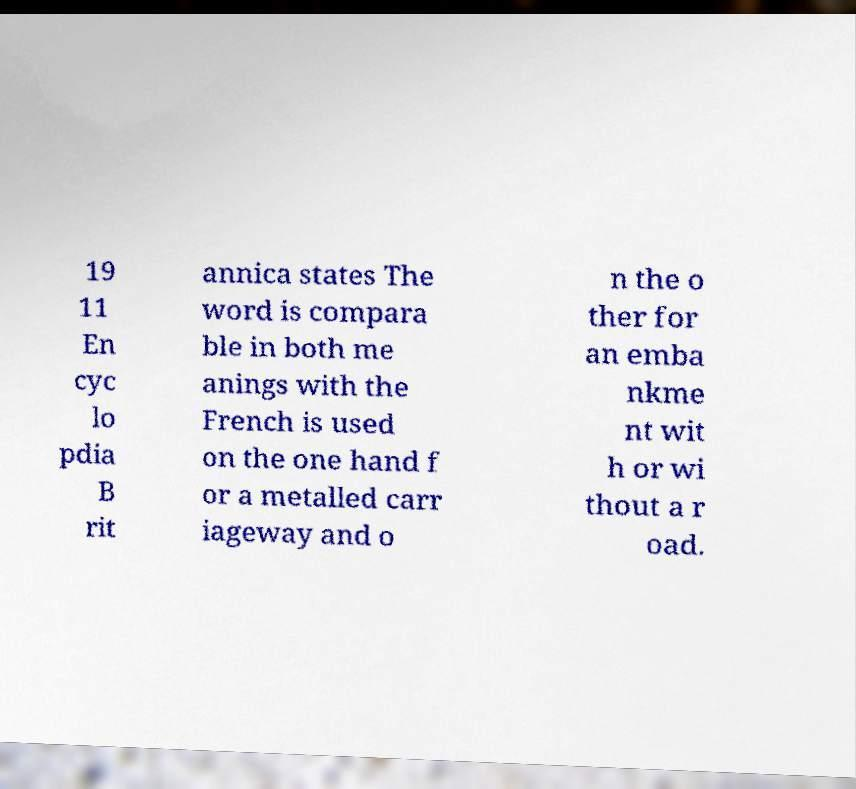What messages or text are displayed in this image? I need them in a readable, typed format. 19 11 En cyc lo pdia B rit annica states The word is compara ble in both me anings with the French is used on the one hand f or a metalled carr iageway and o n the o ther for an emba nkme nt wit h or wi thout a r oad. 